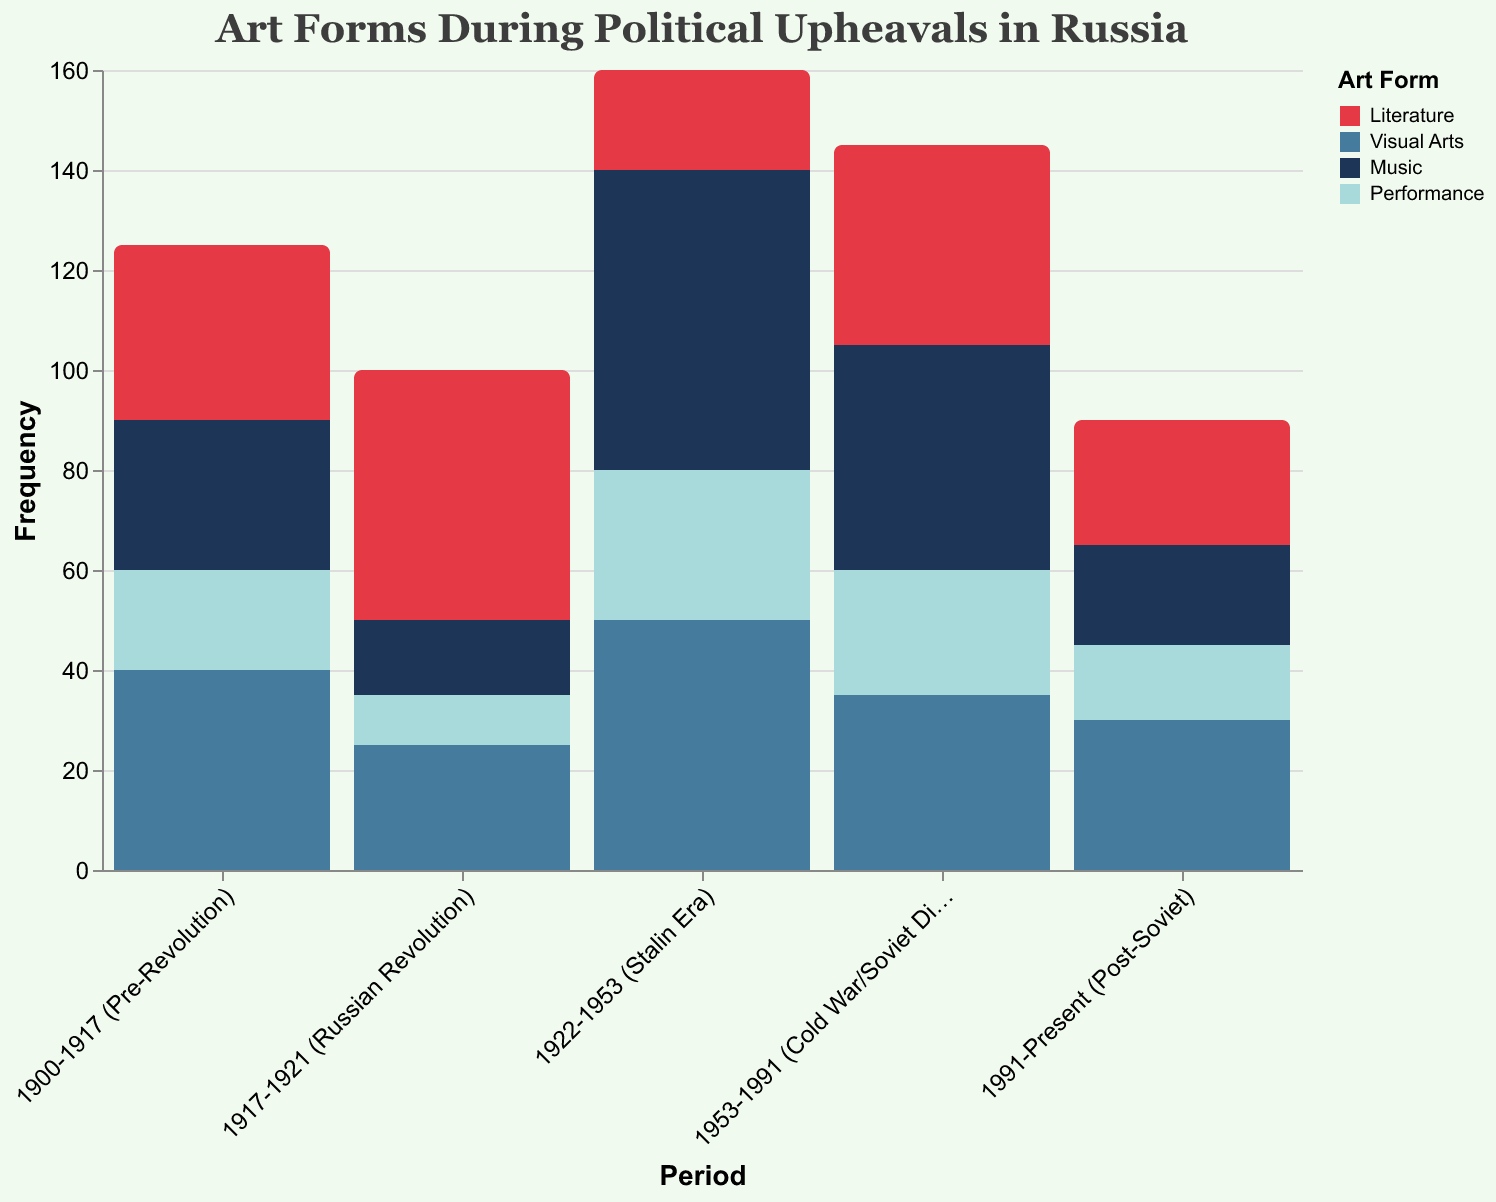What is the title of the figure? The title is placed at the top of the figure and it's clearly stated.
Answer: Art Forms During Political Upheavals in Russia What are the periods covered in the figure? There are four distinct periods represented on the x-axis of the figure. They are labeled as follows: "1900-1917 (Pre-Revolution)", "1917-1921 (Russian Revolution)", "1922-1953 (Stalin Era)", and "1953-1991 (Cold War/Soviet Dissolution)", and "1991-Present (Post-Soviet)".
Answer: 5 periods Which art form had the highest frequency during the Stalin Era? The figure shows various colored bars representing different art forms. The 'Music' category's bar is the tallest during the "1922-1953 (Stalin Era)" period, indicating the highest frequency.
Answer: Music How many art forms experienced a decrease in frequency from the Russian Revolution to the Stalin Era? By comparing the bar heights for each art form between the "1917-1921 (Russian Revolution)" and "1922-1953 (Stalin Era)" periods, we notice the 'Literature' category decreased from 50 to 20, and 'Performance' increased from 10 to 30, while the others increased.
Answer: One What was the total frequency of all art forms combined during the Pre-Revolution period? Adding the frequencies of all art forms given for the "1900-1917 (Pre-Revolution)" period: 35 (Literature) + 40 (Visual Arts) + 30 (Music) + 20 (Performance) = 125.
Answer: 125 Which period experienced a higher frequency of Visual Arts, the Russian Revolution or the Post-Soviet period? Comparing the bar heights for 'Visual Arts' between "1917-1921 (Russian Revolution)" which is 25, and "1991-Present (Post-Soviet)" which is 30, it can be seen that the Post-Soviet period had a higher frequency.
Answer: Post-Soviet period What is the combined frequency of Literature and Performance during the Cold War/Soviet Dissolution? From the "1953-1991 (Cold War/Soviet Dissolution)" period, we add the frequencies of 'Literature' (40) and 'Performance' (25): 40 + 25 = 65.
Answer: 65 Which art form showed the most dramatic change in frequency between the Pre-Revolution and Russian Revolution periods? By checking the differences in the bar heights from "1900-1917 (Pre-Revolution)" to "1917-1921 (Russian Revolution)", 'Literature' increased from 35 to 50 (a difference of 15), 'Visual Arts' dropped from 40 to 25 (a difference of 15), 'Music' dropped by 15, and 'Performance' decreased by 10. The most dramatic change was shown by 'Literature'.
Answer: Literature How did the frequency of Music change from the Stalin Era to the Cold War/Soviet Dissolution period? From the "1922-1953 (Stalin Era)" period, the frequency of 'Music' was 60, and in the "1953-1991 (Cold War/Soviet Dissolution)" period, it was 45. The change is calculated as 60 - 45 = 15.
Answer: Decreased by 15 